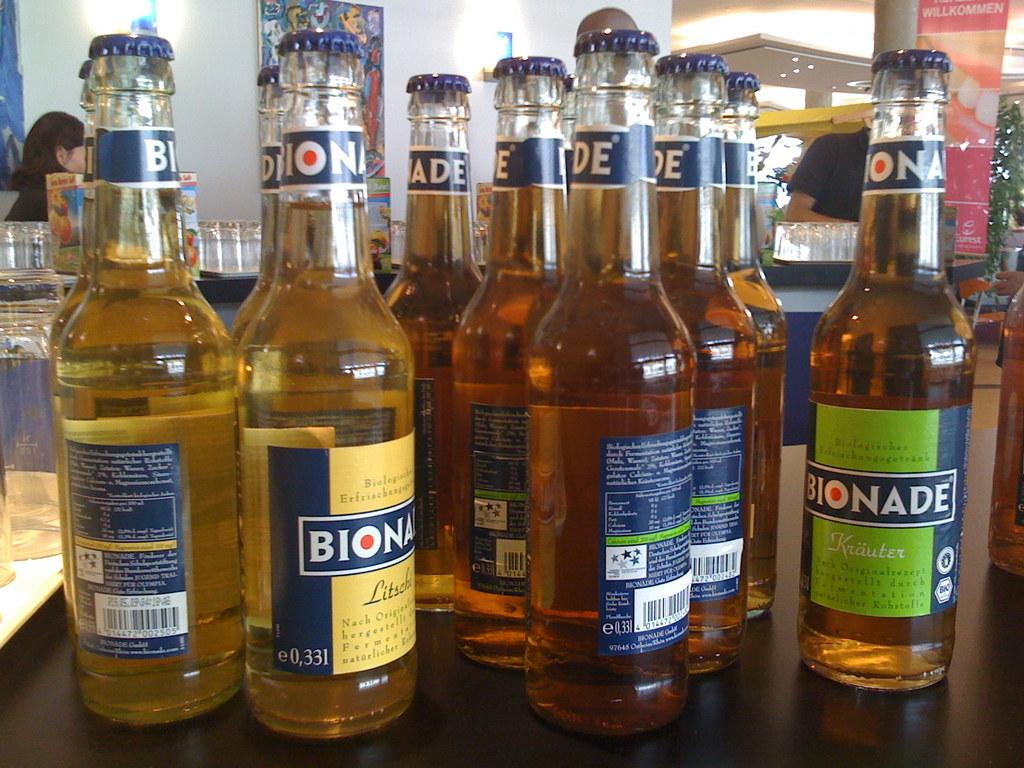Provide a one-sentence caption for the provided image. A multitude of Bionade bottles sit on a counter in a restaurant. 